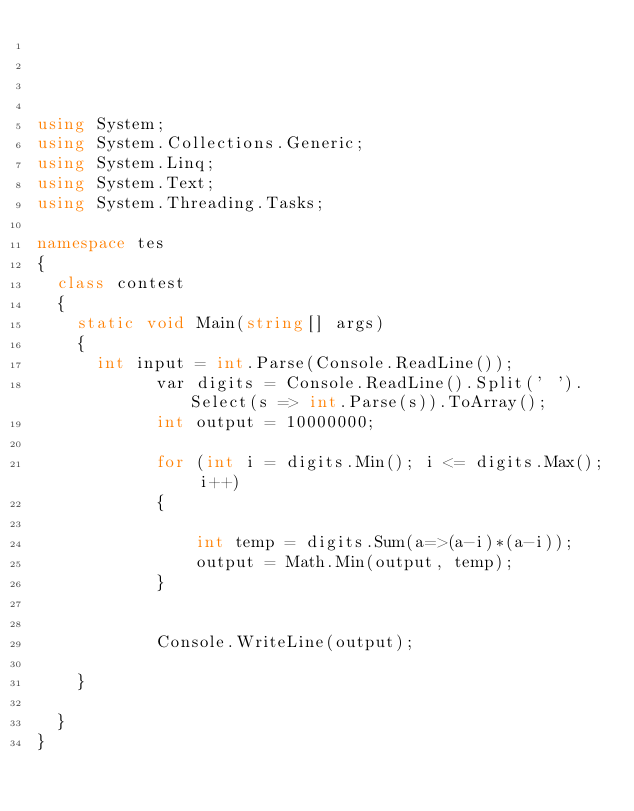Convert code to text. <code><loc_0><loc_0><loc_500><loc_500><_C#_>



using System;
using System.Collections.Generic;
using System.Linq;
using System.Text;
using System.Threading.Tasks;

namespace tes
{
	class contest
	{
		static void Main(string[] args)
		{
			int input = int.Parse(Console.ReadLine());
            var digits = Console.ReadLine().Split(' ').Select(s => int.Parse(s)).ToArray();
            int output = 10000000;

            for (int i = digits.Min(); i <= digits.Max(); i++)
            {
                
                int temp = digits.Sum(a=>(a-i)*(a-i));
                output = Math.Min(output, temp);
            }


            Console.WriteLine(output);
            
		}

	}
}</code> 